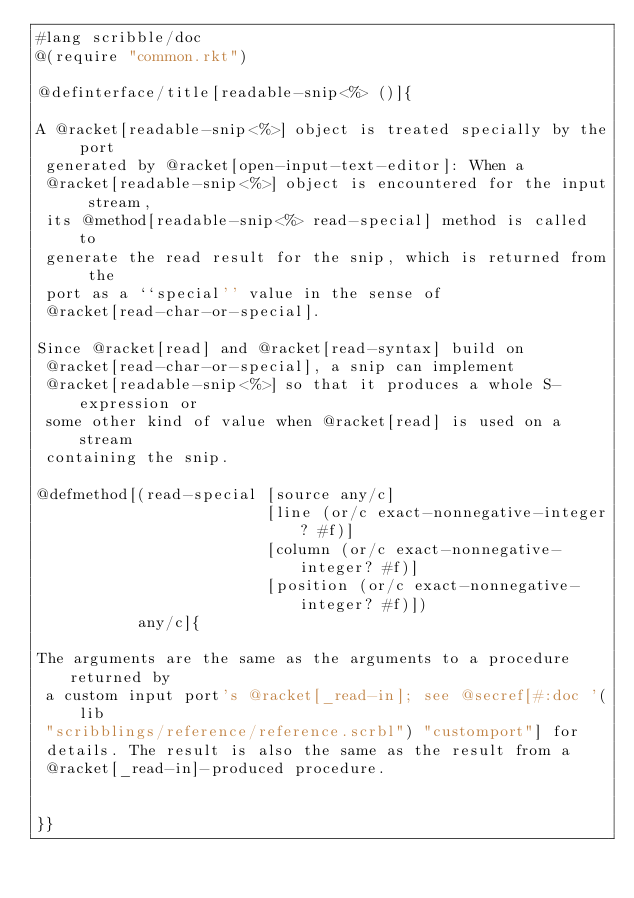Convert code to text. <code><loc_0><loc_0><loc_500><loc_500><_Racket_>#lang scribble/doc
@(require "common.rkt")

@definterface/title[readable-snip<%> ()]{

A @racket[readable-snip<%>] object is treated specially by the port
 generated by @racket[open-input-text-editor]: When a
 @racket[readable-snip<%>] object is encountered for the input stream,
 its @method[readable-snip<%> read-special] method is called to
 generate the read result for the snip, which is returned from the
 port as a ``special'' value in the sense of
 @racket[read-char-or-special].

Since @racket[read] and @racket[read-syntax] build on
 @racket[read-char-or-special], a snip can implement
 @racket[readable-snip<%>] so that it produces a whole S-expression or
 some other kind of value when @racket[read] is used on a stream
 containing the snip.

@defmethod[(read-special [source any/c]
                         [line (or/c exact-nonnegative-integer? #f)]
                         [column (or/c exact-nonnegative-integer? #f)]
                         [position (or/c exact-nonnegative-integer? #f)])
           any/c]{

The arguments are the same as the arguments to a procedure returned by
 a custom input port's @racket[_read-in]; see @secref[#:doc '(lib
 "scribblings/reference/reference.scrbl") "customport"] for
 details. The result is also the same as the result from a
 @racket[_read-in]-produced procedure.


}}

</code> 